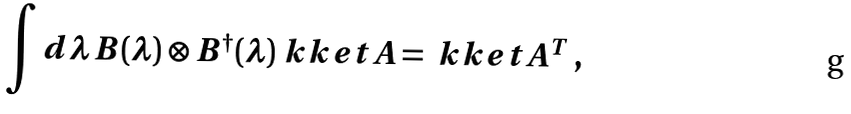Convert formula to latex. <formula><loc_0><loc_0><loc_500><loc_500>\int d \lambda \, B ( \lambda ) \otimes B ^ { \dagger } ( \lambda ) \ k k e t { A } = \ k k e t { A ^ { T } } \, ,</formula> 